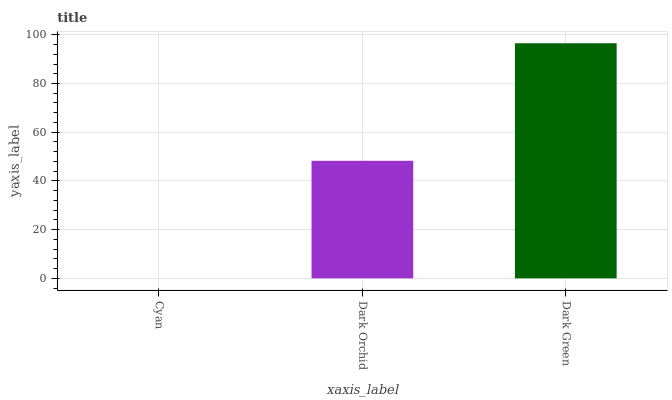Is Cyan the minimum?
Answer yes or no. Yes. Is Dark Green the maximum?
Answer yes or no. Yes. Is Dark Orchid the minimum?
Answer yes or no. No. Is Dark Orchid the maximum?
Answer yes or no. No. Is Dark Orchid greater than Cyan?
Answer yes or no. Yes. Is Cyan less than Dark Orchid?
Answer yes or no. Yes. Is Cyan greater than Dark Orchid?
Answer yes or no. No. Is Dark Orchid less than Cyan?
Answer yes or no. No. Is Dark Orchid the high median?
Answer yes or no. Yes. Is Dark Orchid the low median?
Answer yes or no. Yes. Is Cyan the high median?
Answer yes or no. No. Is Dark Green the low median?
Answer yes or no. No. 